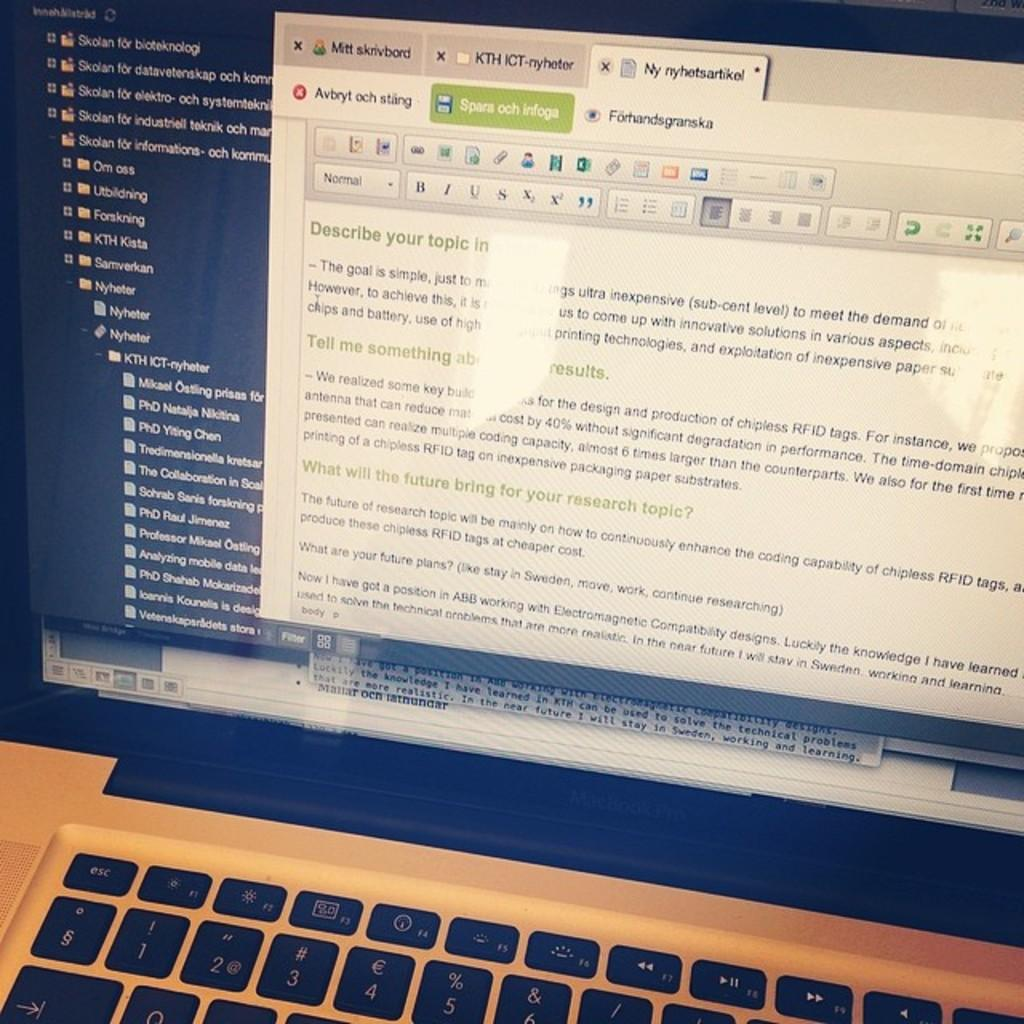Provide a one-sentence caption for the provided image. A laptop screen shows a web page with information about how to describe your topic. 